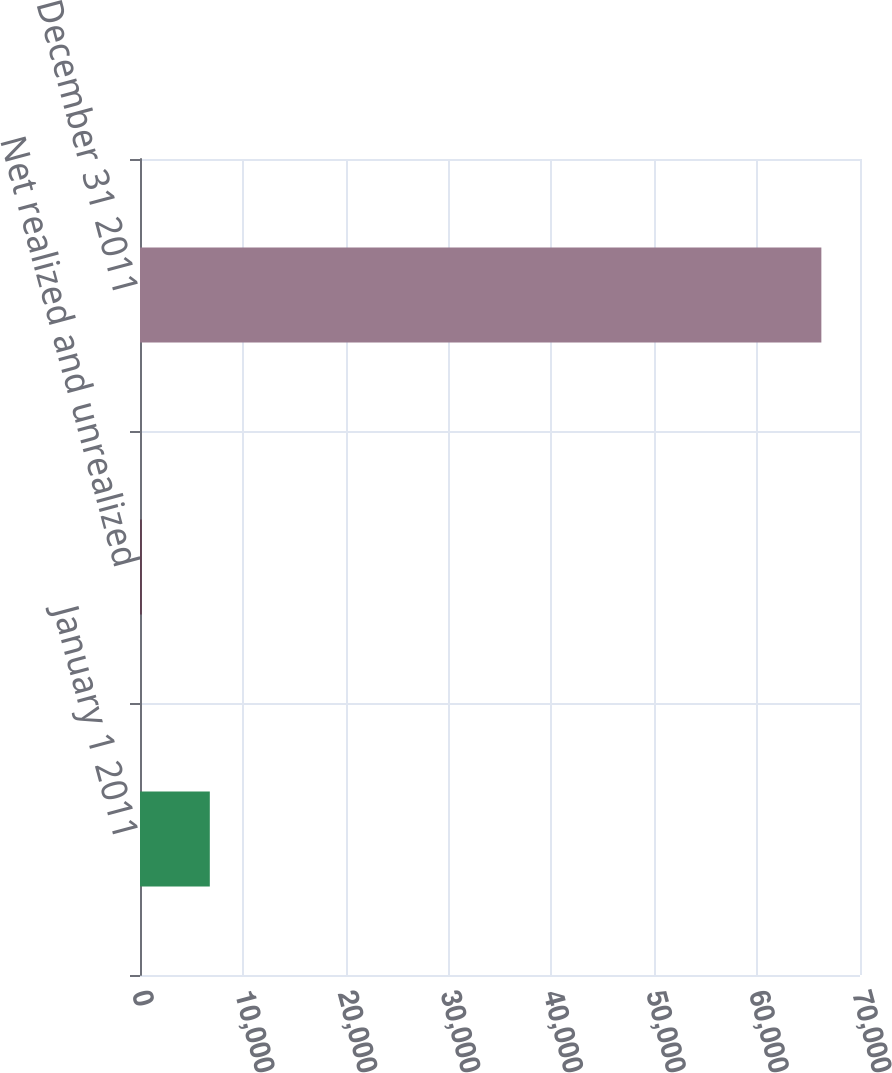Convert chart to OTSL. <chart><loc_0><loc_0><loc_500><loc_500><bar_chart><fcel>January 1 2011<fcel>Net realized and unrealized<fcel>December 31 2011<nl><fcel>6787.2<fcel>181<fcel>66243<nl></chart> 